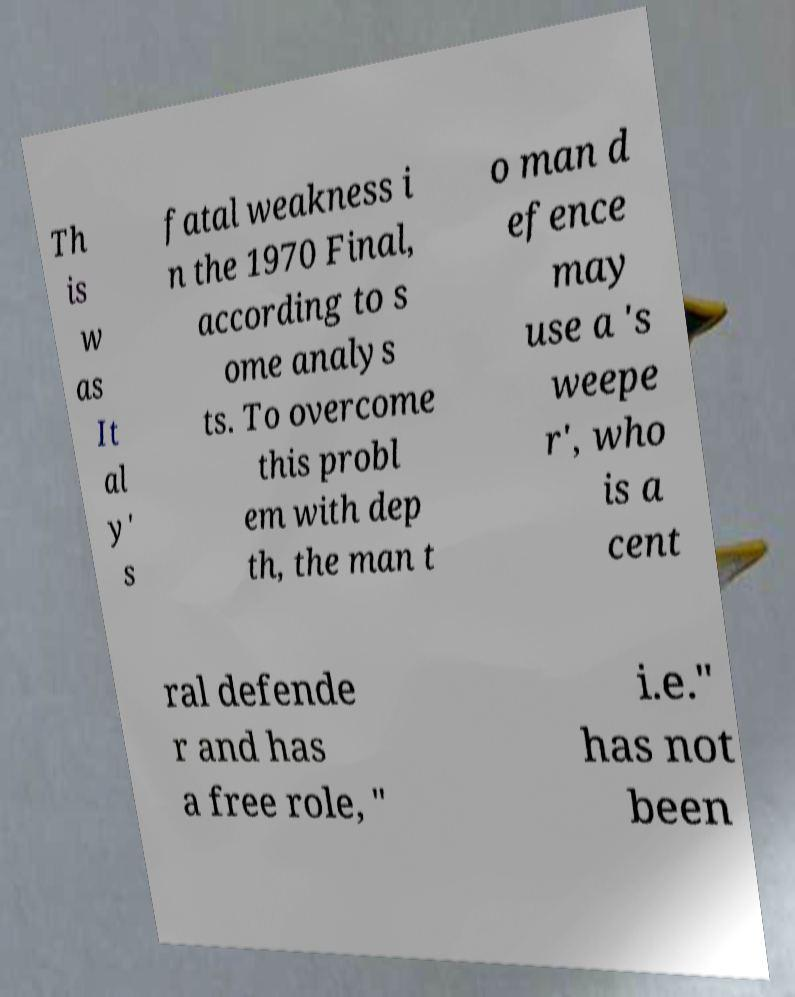Please read and relay the text visible in this image. What does it say? Th is w as It al y' s fatal weakness i n the 1970 Final, according to s ome analys ts. To overcome this probl em with dep th, the man t o man d efence may use a 's weepe r', who is a cent ral defende r and has a free role, " i.e." has not been 